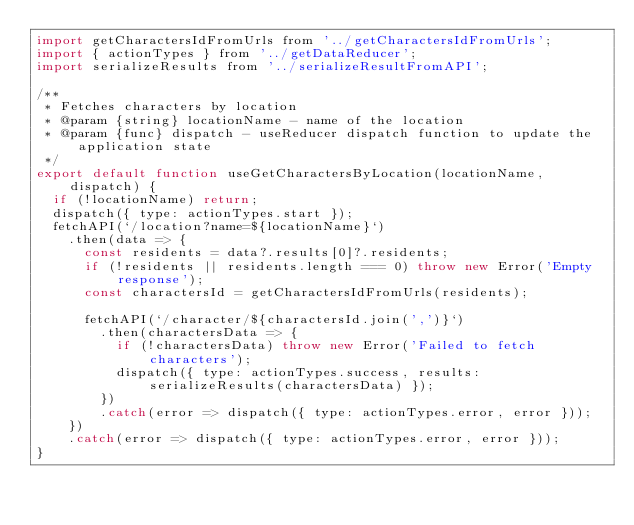<code> <loc_0><loc_0><loc_500><loc_500><_JavaScript_>import getCharactersIdFromUrls from '../getCharactersIdFromUrls';
import { actionTypes } from '../getDataReducer';
import serializeResults from '../serializeResultFromAPI';

/**
 * Fetches characters by location
 * @param {string} locationName - name of the location
 * @param {func} dispatch - useReducer dispatch function to update the application state
 */
export default function useGetCharactersByLocation(locationName, dispatch) {
  if (!locationName) return;
  dispatch({ type: actionTypes.start });
  fetchAPI(`/location?name=${locationName}`)
    .then(data => {
      const residents = data?.results[0]?.residents;
      if (!residents || residents.length === 0) throw new Error('Empty response');
      const charactersId = getCharactersIdFromUrls(residents);

      fetchAPI(`/character/${charactersId.join(',')}`)
        .then(charactersData => {
          if (!charactersData) throw new Error('Failed to fetch characters');
          dispatch({ type: actionTypes.success, results: serializeResults(charactersData) });
        })
        .catch(error => dispatch({ type: actionTypes.error, error }));
    })
    .catch(error => dispatch({ type: actionTypes.error, error }));
}
</code> 